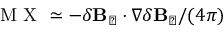Convert formula to latex. <formula><loc_0><loc_0><loc_500><loc_500>M X \simeq - \delta B _ { \perp } \cdot \nabla \delta B _ { \perp } / ( 4 \pi )</formula> 